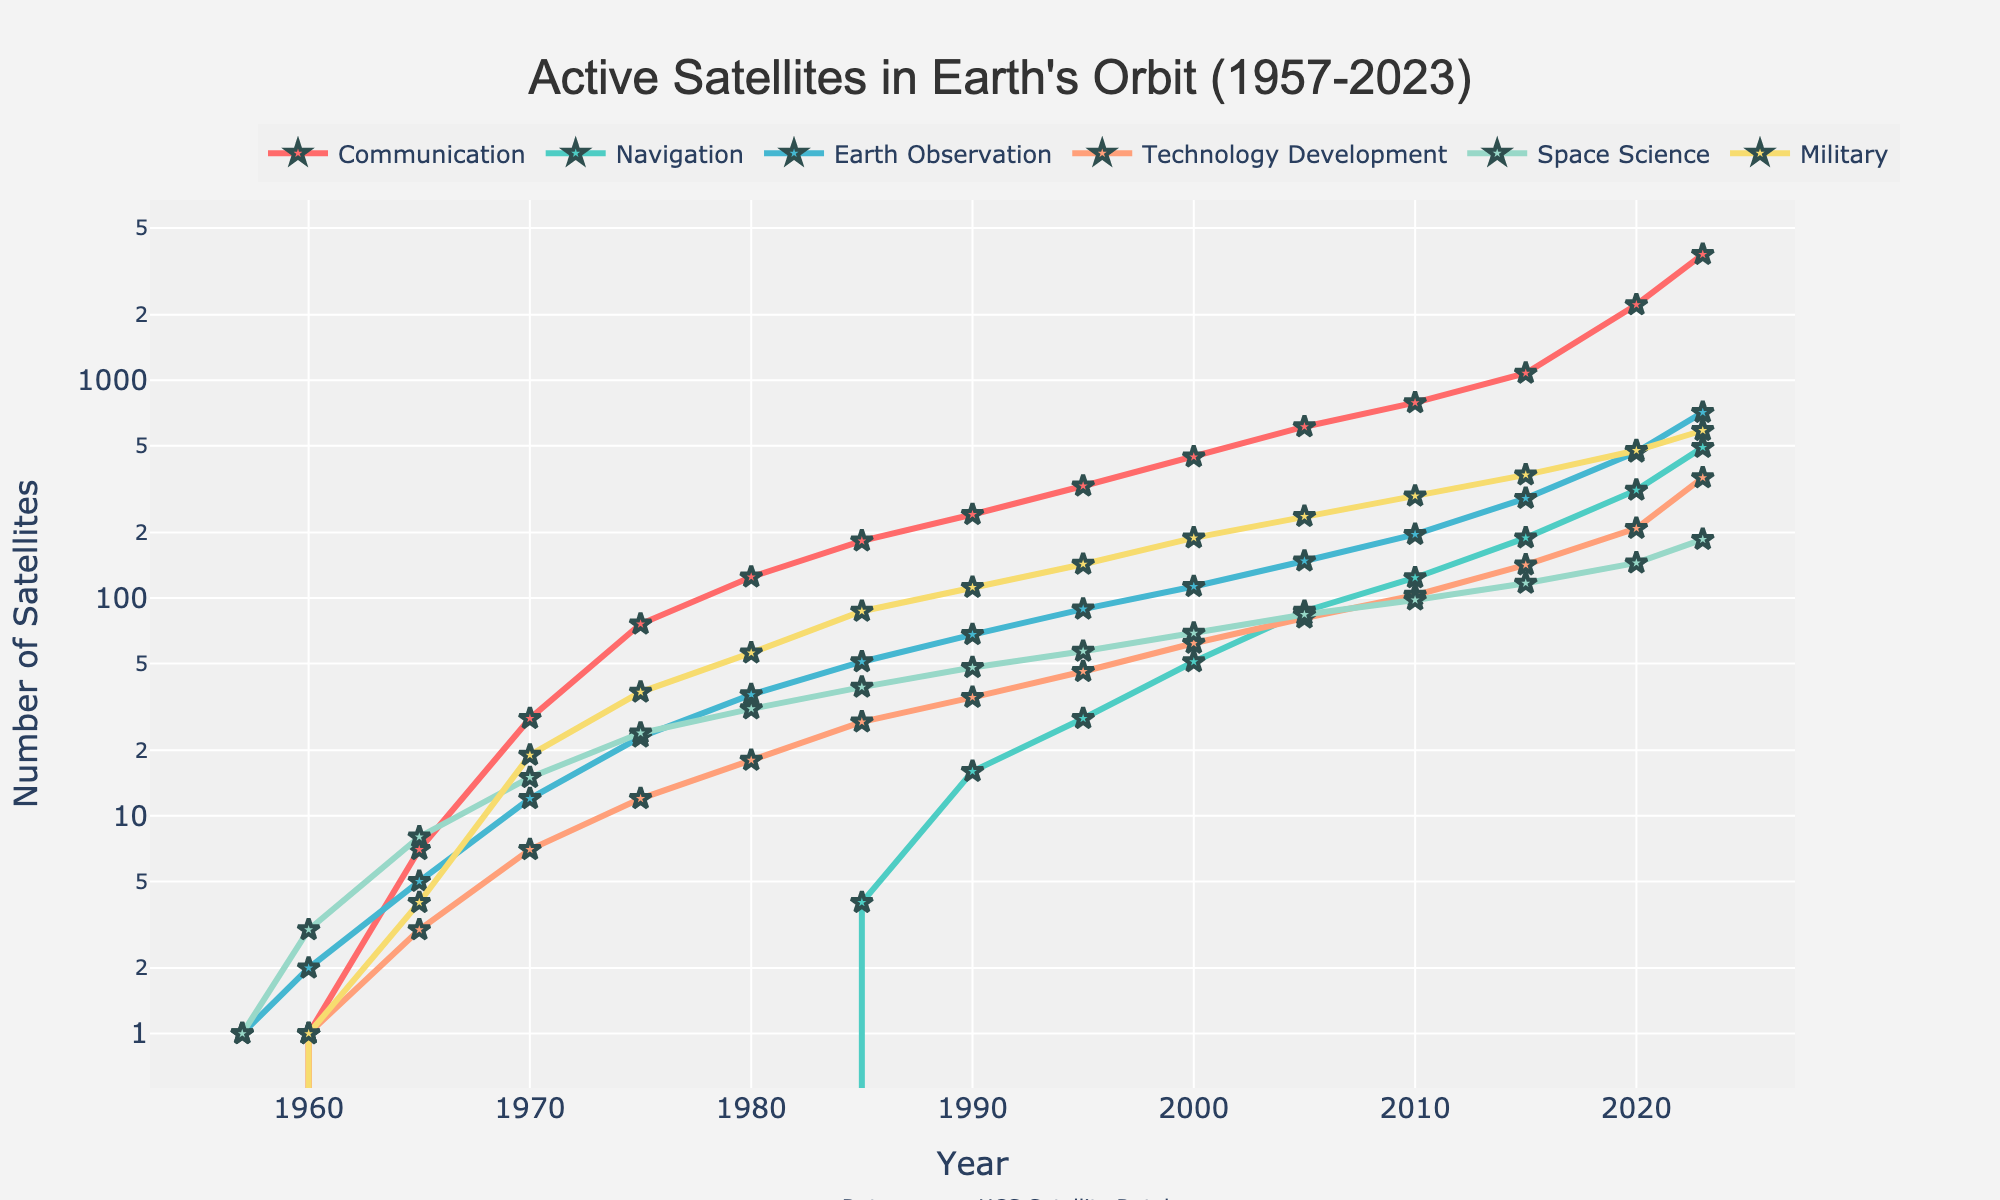What's the overall trend in the number of active communication satellites from 1957 to 2023? The number of active communication satellites has been increasing significantly from 1957 to 2023. Starting with 0 in 1957 and reaching 3785 in 2023, the trend shows a steep rise, especially in recent years.
Answer: Increasing significantly Which category had the most significant growth between 2000 and 2023? By comparing the number of active satellites in 2000 and 2023 for each category, communication satellites grew from 445 to 3785, which is the most significant increase among all categories.
Answer: Communication How many more military satellites were active in 2023 compared to 1980? In 2023, there were 588 military satellites active, compared to 56 in 1980. The increase is calculated by subtracting the 1980 value from the 2023 value, 588 - 56 = 532.
Answer: 532 Which year saw the highest increase in the number of Earth Observation satellites compared to the previous data point? By comparing the differences year by year, the highest increase occurred from 2015 (287) to 2020 (468), which is an increase of 468 - 287 = 181.
Answer: From 2015 to 2020 Compare the number of Space Science satellites in 1990 and 2010. Which year had more and by how much? In 1990, there were 48 Space Science satellites, and in 2010, there were 98. The difference is 98 (2010) - 48 (1990) = 50.
Answer: 2010 by 50 Approximately how many Earth Observation satellites were active in the year 2005? The number of Earth Observation satellites in 2005 can be read directly from the figure, which shows 148 satellites.
Answer: 148 What is the ratio of Technology Development satellites in 2023 compared to 1960? In 2023, there were 357 Technology Development satellites, compared to 1 in 1960. The ratio is found by dividing 357 by 1, resulting in 357:1.
Answer: 357:1 In which period did Miltary satellites see the least growth? By observing the values, we can see that between 1957 and 1960, the number of Military satellites increased by just 1 (from 0 to 1).
Answer: 1957-1960 If you sum the number of Navigation satellites in 1995 and Earth Observation satellites in 1995, what value do you get? In 1995, Navigation satellites were 28, and Earth Observation satellites were 89. The sum is 28 + 89 = 117.
Answer: 117 Which category has consistently had the lowest number of satellites from 1957 to 2023? By examining the lines, Navigation satellites have consistently had the lowest number, except a slight increase in recent years.
Answer: Navigation 